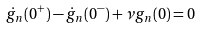Convert formula to latex. <formula><loc_0><loc_0><loc_500><loc_500>\dot { g } _ { n } ( 0 ^ { + } ) - \dot { g } _ { n } ( 0 ^ { - } ) + \nu g _ { n } ( 0 ) = 0</formula> 